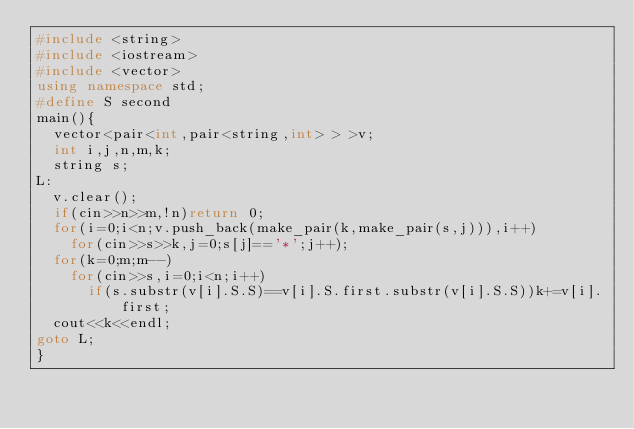Convert code to text. <code><loc_0><loc_0><loc_500><loc_500><_C++_>#include <string>
#include <iostream>
#include <vector>
using namespace std;
#define S second
main(){
  vector<pair<int,pair<string,int> > >v;
  int i,j,n,m,k;
  string s;
L:
  v.clear();
  if(cin>>n>>m,!n)return 0;
  for(i=0;i<n;v.push_back(make_pair(k,make_pair(s,j))),i++)
    for(cin>>s>>k,j=0;s[j]=='*';j++);
  for(k=0;m;m--)
    for(cin>>s,i=0;i<n;i++)
      if(s.substr(v[i].S.S)==v[i].S.first.substr(v[i].S.S))k+=v[i].first;
  cout<<k<<endl;
goto L;
}</code> 